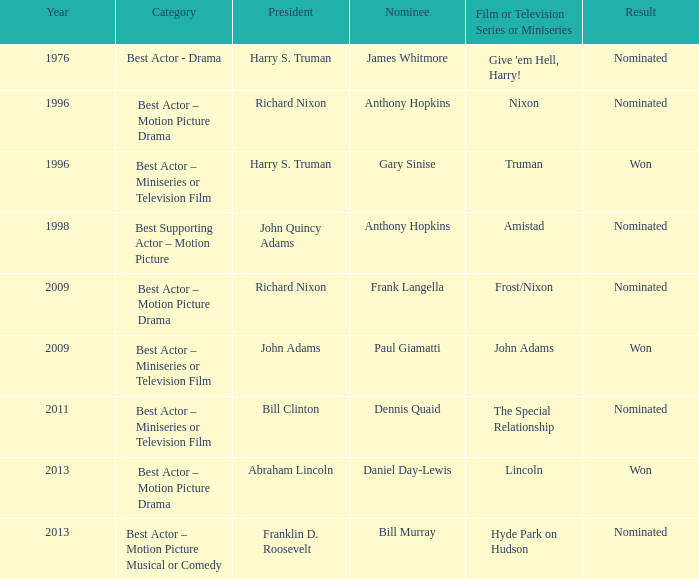What was the result of Frank Langella? Nominated. 